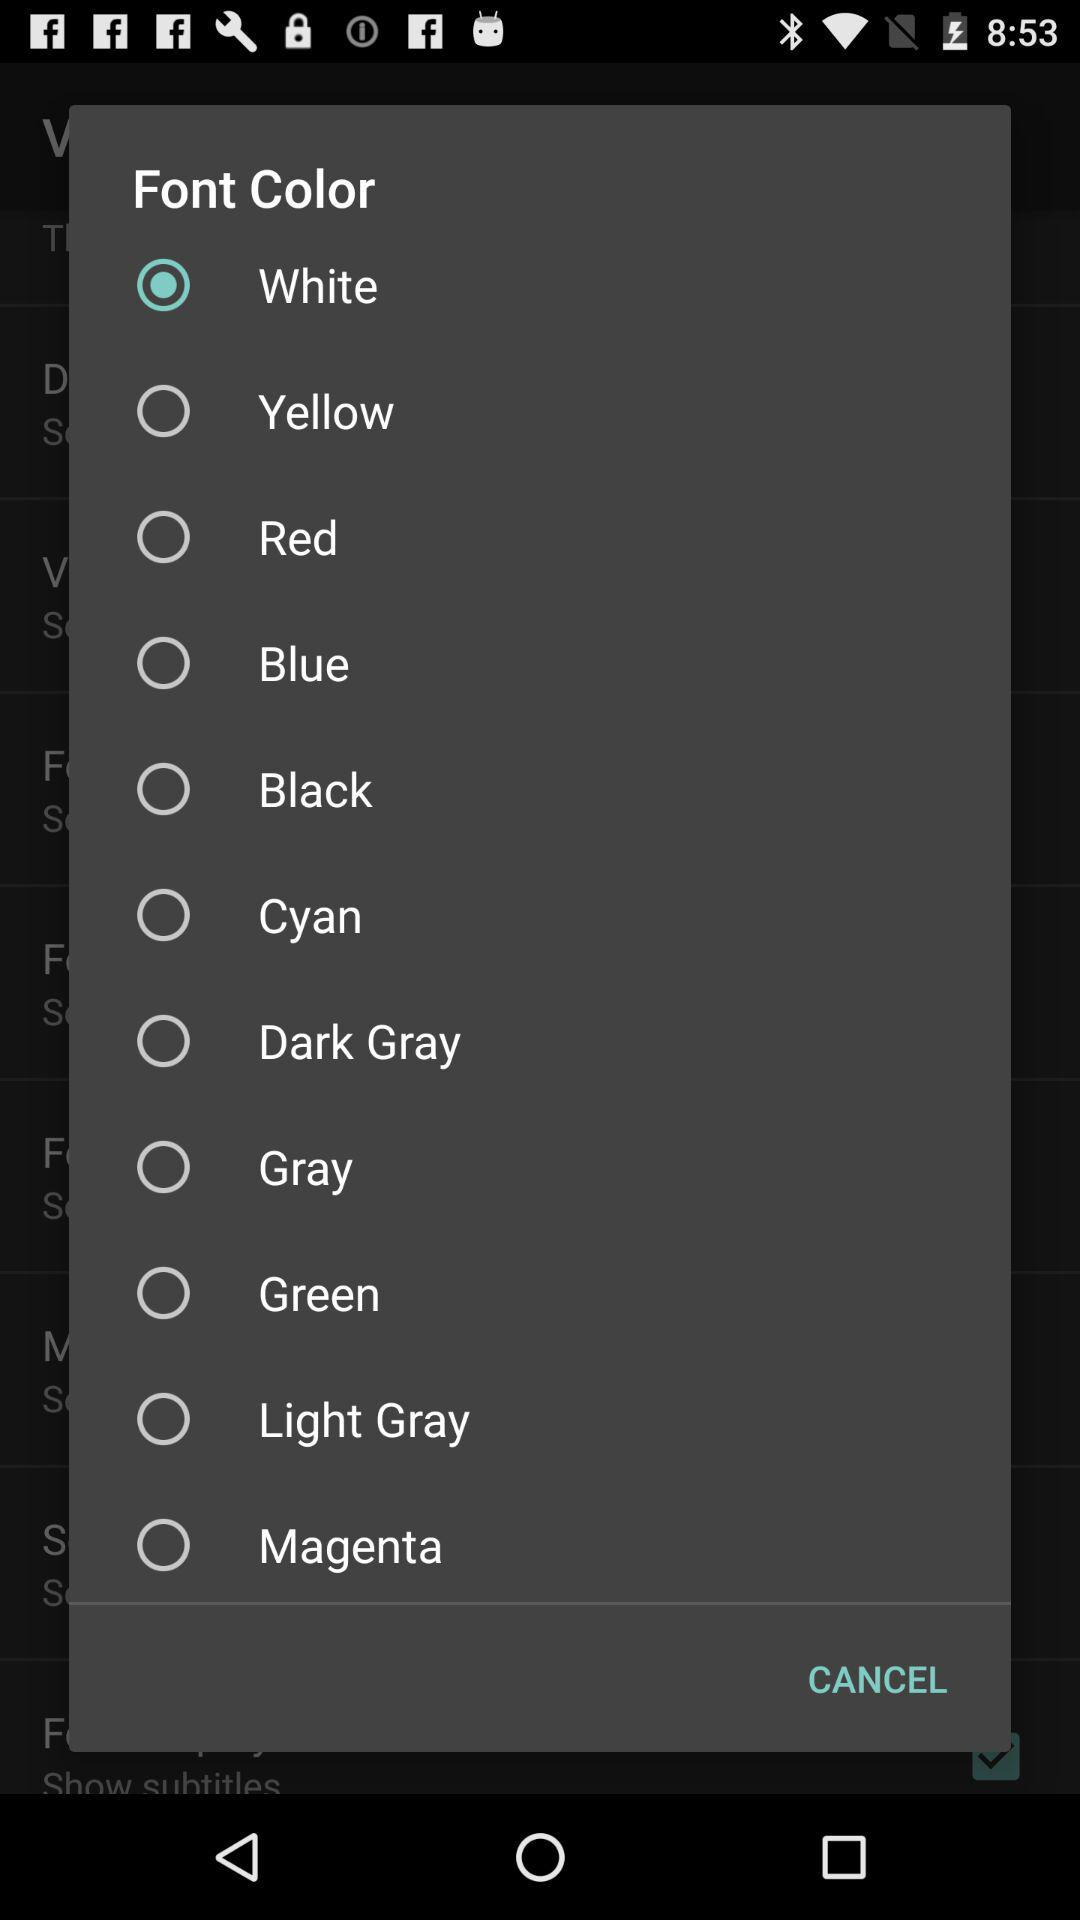What are the different available font color options? The different available font color options are "White", "Yellow", "Red", "Blue", "Black", "Cyan", "Dark Gray", "Gray", "Green", "Light Gray" and "Magenta". 